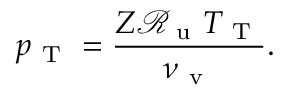Convert formula to latex. <formula><loc_0><loc_0><loc_500><loc_500>p _ { T } = \frac { Z \mathcal { R } _ { u } T _ { T } } { \nu _ { v } } .</formula> 